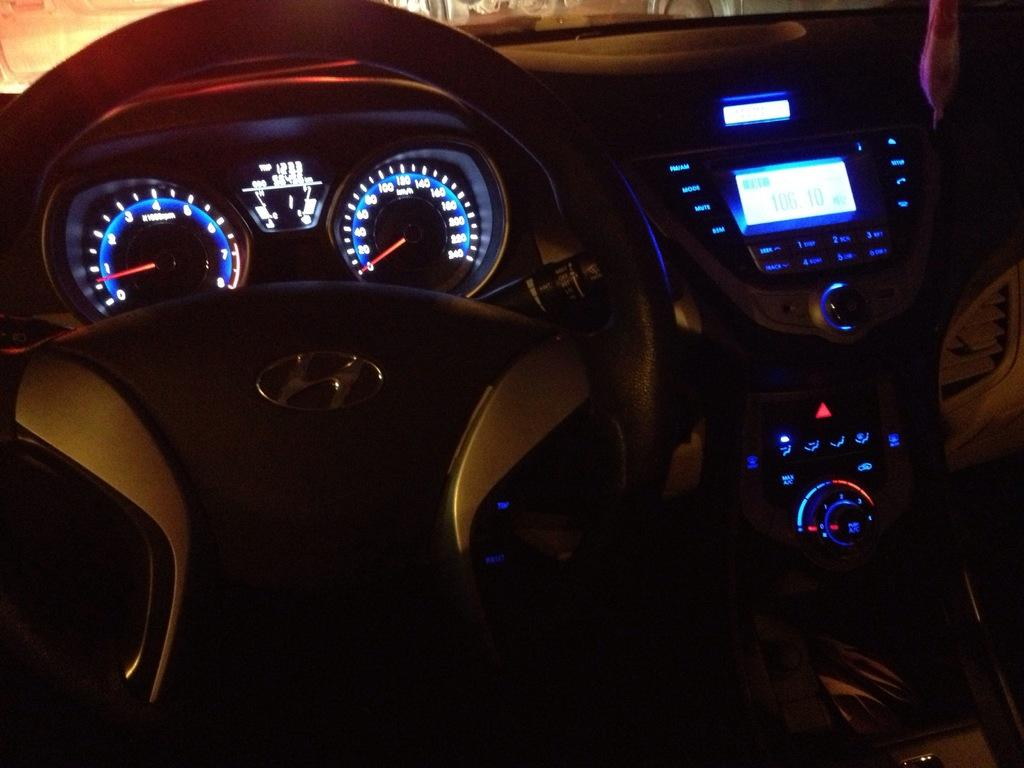What type of vehicle is shown in the image? The image shows an inner view of a car. What is the main control device in the car? There is a steering wheel in the image. What can be seen on the dashboard of the car? There are functioning buttons visible in the image. Can you see any waves or sea creatures in the image? No, there are no waves or sea creatures present in the image; it shows the interior of a car. 